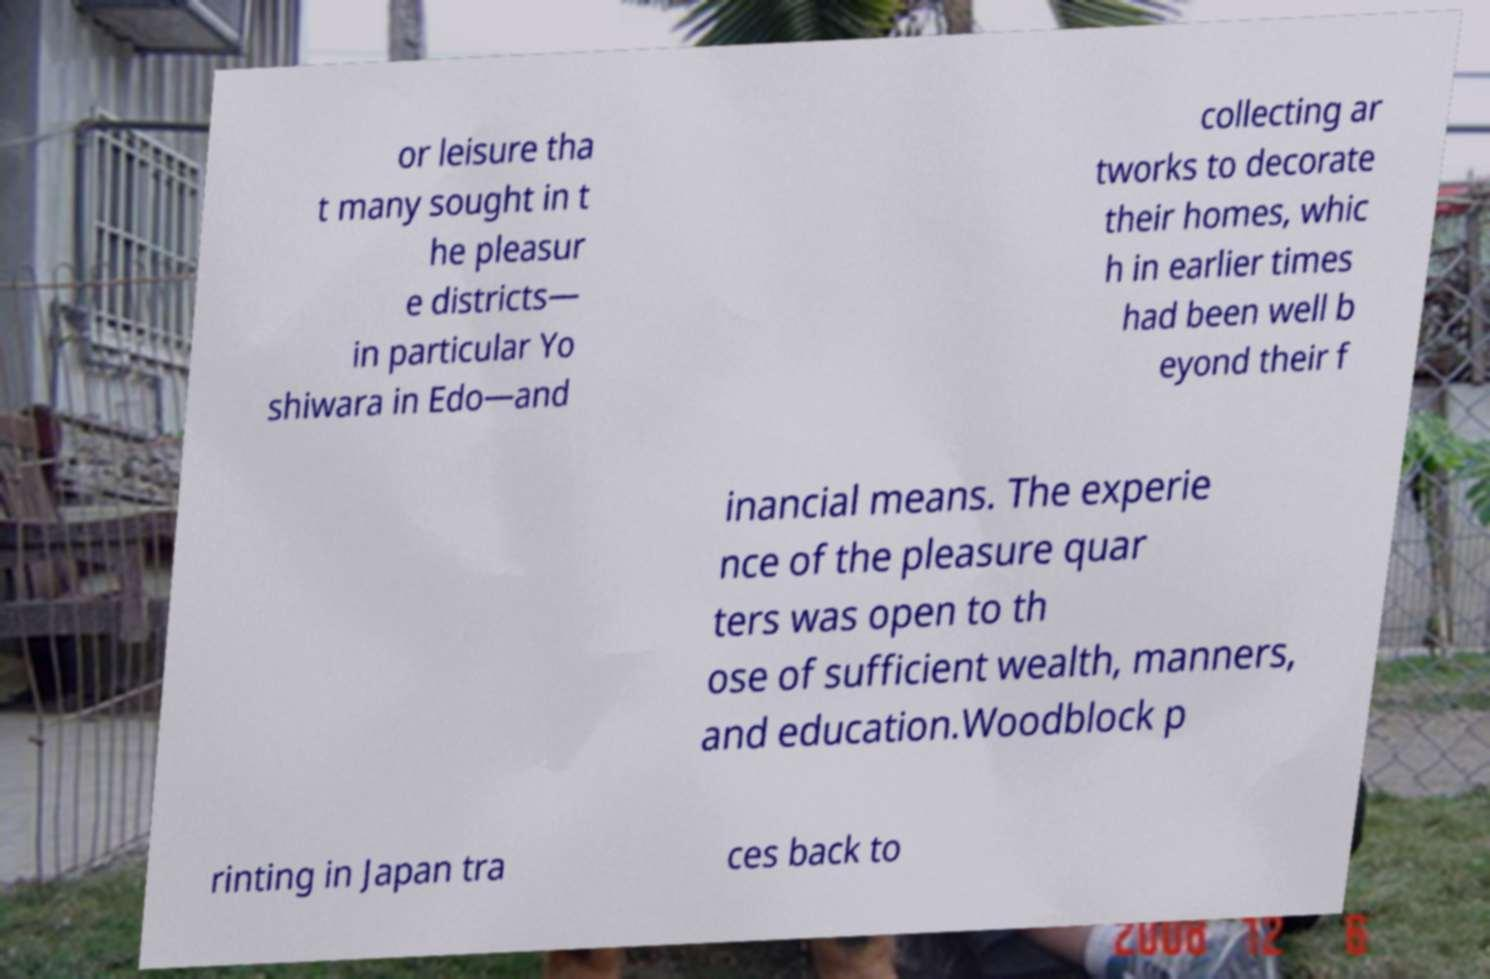I need the written content from this picture converted into text. Can you do that? or leisure tha t many sought in t he pleasur e districts— in particular Yo shiwara in Edo—and collecting ar tworks to decorate their homes, whic h in earlier times had been well b eyond their f inancial means. The experie nce of the pleasure quar ters was open to th ose of sufficient wealth, manners, and education.Woodblock p rinting in Japan tra ces back to 